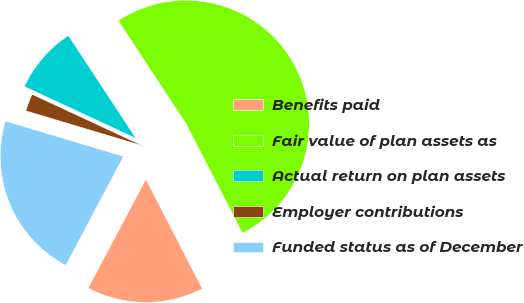<chart> <loc_0><loc_0><loc_500><loc_500><pie_chart><fcel>Benefits paid<fcel>Fair value of plan assets as<fcel>Actual return on plan assets<fcel>Employer contributions<fcel>Funded status as of December<nl><fcel>15.34%<fcel>51.68%<fcel>8.82%<fcel>2.29%<fcel>21.87%<nl></chart> 